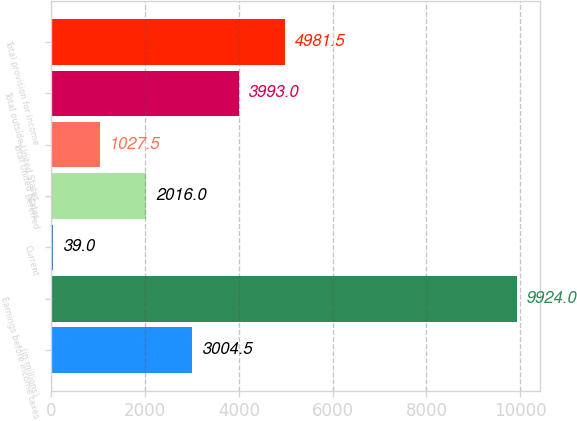<chart> <loc_0><loc_0><loc_500><loc_500><bar_chart><fcel>(in millions)<fcel>Earnings before income taxes<fcel>Current<fcel>Deferred<fcel>Total United States<fcel>Total outside United States<fcel>Total provision for income<nl><fcel>3004.5<fcel>9924<fcel>39<fcel>2016<fcel>1027.5<fcel>3993<fcel>4981.5<nl></chart> 